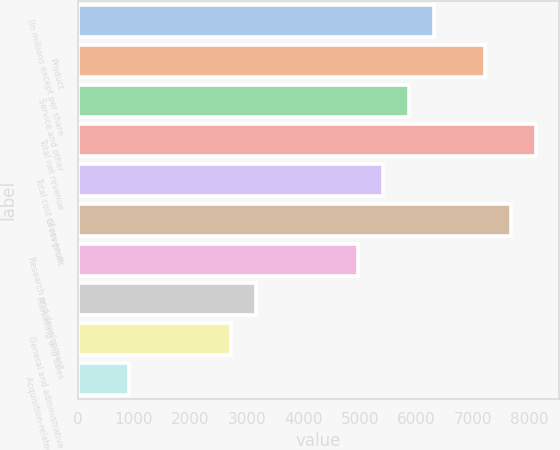<chart> <loc_0><loc_0><loc_500><loc_500><bar_chart><fcel>(In millions except per share<fcel>Product<fcel>Service and other<fcel>Total net revenue<fcel>Total cost of revenue<fcel>Gross profit<fcel>Research and development<fcel>Marketing and sales<fcel>General and administrative<fcel>Acquisition-related contingent<nl><fcel>6319.91<fcel>7222.37<fcel>5868.68<fcel>8124.83<fcel>5417.45<fcel>7673.6<fcel>4966.22<fcel>3161.3<fcel>2710.07<fcel>905.15<nl></chart> 